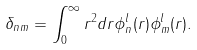Convert formula to latex. <formula><loc_0><loc_0><loc_500><loc_500>\delta _ { n m } = \int _ { 0 } ^ { \infty } r ^ { 2 } d r \phi _ { n } ^ { l } ( r ) \phi _ { m } ^ { l } ( r ) .</formula> 